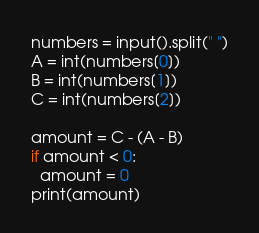<code> <loc_0><loc_0><loc_500><loc_500><_Python_>numbers = input().split(" ")
A = int(numbers[0])
B = int(numbers[1])
C = int(numbers[2])

amount = C - (A - B)
if amount < 0:
  amount = 0
print(amount)</code> 